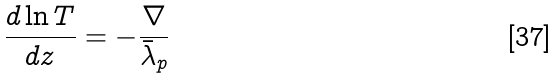Convert formula to latex. <formula><loc_0><loc_0><loc_500><loc_500>\frac { d \ln T } { d z } = - \frac { \nabla } { \bar { \lambda } _ { p } }</formula> 